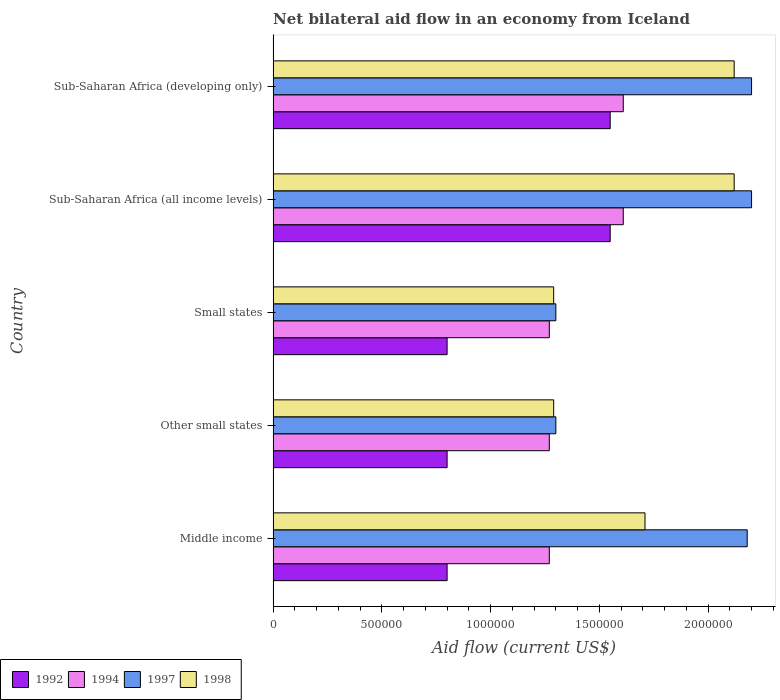Are the number of bars per tick equal to the number of legend labels?
Ensure brevity in your answer.  Yes. What is the label of the 3rd group of bars from the top?
Give a very brief answer. Small states. What is the net bilateral aid flow in 1994 in Small states?
Provide a succinct answer. 1.27e+06. Across all countries, what is the maximum net bilateral aid flow in 1998?
Offer a terse response. 2.12e+06. Across all countries, what is the minimum net bilateral aid flow in 1997?
Offer a terse response. 1.30e+06. In which country was the net bilateral aid flow in 1994 maximum?
Offer a very short reply. Sub-Saharan Africa (all income levels). What is the total net bilateral aid flow in 1992 in the graph?
Offer a terse response. 5.50e+06. What is the difference between the net bilateral aid flow in 1994 in Small states and that in Sub-Saharan Africa (all income levels)?
Your response must be concise. -3.40e+05. What is the difference between the net bilateral aid flow in 1992 in Sub-Saharan Africa (all income levels) and the net bilateral aid flow in 1997 in Sub-Saharan Africa (developing only)?
Keep it short and to the point. -6.50e+05. What is the average net bilateral aid flow in 1994 per country?
Your answer should be compact. 1.41e+06. What is the ratio of the net bilateral aid flow in 1992 in Sub-Saharan Africa (all income levels) to that in Sub-Saharan Africa (developing only)?
Offer a terse response. 1. Is the difference between the net bilateral aid flow in 1998 in Middle income and Sub-Saharan Africa (all income levels) greater than the difference between the net bilateral aid flow in 1994 in Middle income and Sub-Saharan Africa (all income levels)?
Keep it short and to the point. No. What is the difference between the highest and the second highest net bilateral aid flow in 1994?
Provide a short and direct response. 0. What is the difference between the highest and the lowest net bilateral aid flow in 1998?
Ensure brevity in your answer.  8.30e+05. Is it the case that in every country, the sum of the net bilateral aid flow in 1992 and net bilateral aid flow in 1997 is greater than the sum of net bilateral aid flow in 1994 and net bilateral aid flow in 1998?
Your answer should be compact. No. How many bars are there?
Provide a succinct answer. 20. How many countries are there in the graph?
Provide a succinct answer. 5. What is the difference between two consecutive major ticks on the X-axis?
Keep it short and to the point. 5.00e+05. Does the graph contain any zero values?
Ensure brevity in your answer.  No. How are the legend labels stacked?
Give a very brief answer. Horizontal. What is the title of the graph?
Your answer should be very brief. Net bilateral aid flow in an economy from Iceland. Does "2015" appear as one of the legend labels in the graph?
Ensure brevity in your answer.  No. What is the Aid flow (current US$) of 1992 in Middle income?
Offer a terse response. 8.00e+05. What is the Aid flow (current US$) in 1994 in Middle income?
Give a very brief answer. 1.27e+06. What is the Aid flow (current US$) of 1997 in Middle income?
Offer a terse response. 2.18e+06. What is the Aid flow (current US$) in 1998 in Middle income?
Offer a terse response. 1.71e+06. What is the Aid flow (current US$) in 1994 in Other small states?
Ensure brevity in your answer.  1.27e+06. What is the Aid flow (current US$) of 1997 in Other small states?
Give a very brief answer. 1.30e+06. What is the Aid flow (current US$) in 1998 in Other small states?
Your answer should be compact. 1.29e+06. What is the Aid flow (current US$) of 1992 in Small states?
Ensure brevity in your answer.  8.00e+05. What is the Aid flow (current US$) of 1994 in Small states?
Offer a very short reply. 1.27e+06. What is the Aid flow (current US$) in 1997 in Small states?
Ensure brevity in your answer.  1.30e+06. What is the Aid flow (current US$) in 1998 in Small states?
Give a very brief answer. 1.29e+06. What is the Aid flow (current US$) of 1992 in Sub-Saharan Africa (all income levels)?
Ensure brevity in your answer.  1.55e+06. What is the Aid flow (current US$) of 1994 in Sub-Saharan Africa (all income levels)?
Keep it short and to the point. 1.61e+06. What is the Aid flow (current US$) in 1997 in Sub-Saharan Africa (all income levels)?
Give a very brief answer. 2.20e+06. What is the Aid flow (current US$) of 1998 in Sub-Saharan Africa (all income levels)?
Ensure brevity in your answer.  2.12e+06. What is the Aid flow (current US$) in 1992 in Sub-Saharan Africa (developing only)?
Your response must be concise. 1.55e+06. What is the Aid flow (current US$) of 1994 in Sub-Saharan Africa (developing only)?
Ensure brevity in your answer.  1.61e+06. What is the Aid flow (current US$) of 1997 in Sub-Saharan Africa (developing only)?
Your answer should be very brief. 2.20e+06. What is the Aid flow (current US$) in 1998 in Sub-Saharan Africa (developing only)?
Give a very brief answer. 2.12e+06. Across all countries, what is the maximum Aid flow (current US$) in 1992?
Your answer should be compact. 1.55e+06. Across all countries, what is the maximum Aid flow (current US$) of 1994?
Keep it short and to the point. 1.61e+06. Across all countries, what is the maximum Aid flow (current US$) in 1997?
Ensure brevity in your answer.  2.20e+06. Across all countries, what is the maximum Aid flow (current US$) in 1998?
Your response must be concise. 2.12e+06. Across all countries, what is the minimum Aid flow (current US$) of 1992?
Give a very brief answer. 8.00e+05. Across all countries, what is the minimum Aid flow (current US$) of 1994?
Ensure brevity in your answer.  1.27e+06. Across all countries, what is the minimum Aid flow (current US$) in 1997?
Keep it short and to the point. 1.30e+06. Across all countries, what is the minimum Aid flow (current US$) in 1998?
Offer a very short reply. 1.29e+06. What is the total Aid flow (current US$) in 1992 in the graph?
Give a very brief answer. 5.50e+06. What is the total Aid flow (current US$) in 1994 in the graph?
Keep it short and to the point. 7.03e+06. What is the total Aid flow (current US$) of 1997 in the graph?
Your response must be concise. 9.18e+06. What is the total Aid flow (current US$) in 1998 in the graph?
Your answer should be compact. 8.53e+06. What is the difference between the Aid flow (current US$) of 1992 in Middle income and that in Other small states?
Your response must be concise. 0. What is the difference between the Aid flow (current US$) in 1994 in Middle income and that in Other small states?
Keep it short and to the point. 0. What is the difference between the Aid flow (current US$) in 1997 in Middle income and that in Other small states?
Your answer should be very brief. 8.80e+05. What is the difference between the Aid flow (current US$) in 1998 in Middle income and that in Other small states?
Provide a succinct answer. 4.20e+05. What is the difference between the Aid flow (current US$) in 1992 in Middle income and that in Small states?
Provide a succinct answer. 0. What is the difference between the Aid flow (current US$) in 1994 in Middle income and that in Small states?
Make the answer very short. 0. What is the difference between the Aid flow (current US$) in 1997 in Middle income and that in Small states?
Give a very brief answer. 8.80e+05. What is the difference between the Aid flow (current US$) in 1992 in Middle income and that in Sub-Saharan Africa (all income levels)?
Your response must be concise. -7.50e+05. What is the difference between the Aid flow (current US$) of 1998 in Middle income and that in Sub-Saharan Africa (all income levels)?
Ensure brevity in your answer.  -4.10e+05. What is the difference between the Aid flow (current US$) of 1992 in Middle income and that in Sub-Saharan Africa (developing only)?
Offer a terse response. -7.50e+05. What is the difference between the Aid flow (current US$) of 1998 in Middle income and that in Sub-Saharan Africa (developing only)?
Provide a short and direct response. -4.10e+05. What is the difference between the Aid flow (current US$) of 1992 in Other small states and that in Small states?
Provide a succinct answer. 0. What is the difference between the Aid flow (current US$) in 1998 in Other small states and that in Small states?
Make the answer very short. 0. What is the difference between the Aid flow (current US$) in 1992 in Other small states and that in Sub-Saharan Africa (all income levels)?
Your answer should be compact. -7.50e+05. What is the difference between the Aid flow (current US$) in 1997 in Other small states and that in Sub-Saharan Africa (all income levels)?
Your answer should be compact. -9.00e+05. What is the difference between the Aid flow (current US$) of 1998 in Other small states and that in Sub-Saharan Africa (all income levels)?
Keep it short and to the point. -8.30e+05. What is the difference between the Aid flow (current US$) in 1992 in Other small states and that in Sub-Saharan Africa (developing only)?
Provide a succinct answer. -7.50e+05. What is the difference between the Aid flow (current US$) in 1997 in Other small states and that in Sub-Saharan Africa (developing only)?
Your response must be concise. -9.00e+05. What is the difference between the Aid flow (current US$) of 1998 in Other small states and that in Sub-Saharan Africa (developing only)?
Your answer should be compact. -8.30e+05. What is the difference between the Aid flow (current US$) of 1992 in Small states and that in Sub-Saharan Africa (all income levels)?
Provide a short and direct response. -7.50e+05. What is the difference between the Aid flow (current US$) in 1997 in Small states and that in Sub-Saharan Africa (all income levels)?
Your response must be concise. -9.00e+05. What is the difference between the Aid flow (current US$) of 1998 in Small states and that in Sub-Saharan Africa (all income levels)?
Offer a very short reply. -8.30e+05. What is the difference between the Aid flow (current US$) in 1992 in Small states and that in Sub-Saharan Africa (developing only)?
Provide a short and direct response. -7.50e+05. What is the difference between the Aid flow (current US$) of 1997 in Small states and that in Sub-Saharan Africa (developing only)?
Offer a very short reply. -9.00e+05. What is the difference between the Aid flow (current US$) in 1998 in Small states and that in Sub-Saharan Africa (developing only)?
Your answer should be compact. -8.30e+05. What is the difference between the Aid flow (current US$) of 1992 in Sub-Saharan Africa (all income levels) and that in Sub-Saharan Africa (developing only)?
Your response must be concise. 0. What is the difference between the Aid flow (current US$) of 1997 in Sub-Saharan Africa (all income levels) and that in Sub-Saharan Africa (developing only)?
Offer a terse response. 0. What is the difference between the Aid flow (current US$) of 1992 in Middle income and the Aid flow (current US$) of 1994 in Other small states?
Your answer should be compact. -4.70e+05. What is the difference between the Aid flow (current US$) in 1992 in Middle income and the Aid flow (current US$) in 1997 in Other small states?
Your answer should be very brief. -5.00e+05. What is the difference between the Aid flow (current US$) in 1992 in Middle income and the Aid flow (current US$) in 1998 in Other small states?
Offer a very short reply. -4.90e+05. What is the difference between the Aid flow (current US$) in 1994 in Middle income and the Aid flow (current US$) in 1997 in Other small states?
Provide a succinct answer. -3.00e+04. What is the difference between the Aid flow (current US$) of 1997 in Middle income and the Aid flow (current US$) of 1998 in Other small states?
Provide a short and direct response. 8.90e+05. What is the difference between the Aid flow (current US$) of 1992 in Middle income and the Aid flow (current US$) of 1994 in Small states?
Give a very brief answer. -4.70e+05. What is the difference between the Aid flow (current US$) in 1992 in Middle income and the Aid flow (current US$) in 1997 in Small states?
Provide a short and direct response. -5.00e+05. What is the difference between the Aid flow (current US$) of 1992 in Middle income and the Aid flow (current US$) of 1998 in Small states?
Offer a very short reply. -4.90e+05. What is the difference between the Aid flow (current US$) of 1994 in Middle income and the Aid flow (current US$) of 1997 in Small states?
Make the answer very short. -3.00e+04. What is the difference between the Aid flow (current US$) of 1994 in Middle income and the Aid flow (current US$) of 1998 in Small states?
Your answer should be very brief. -2.00e+04. What is the difference between the Aid flow (current US$) in 1997 in Middle income and the Aid flow (current US$) in 1998 in Small states?
Provide a short and direct response. 8.90e+05. What is the difference between the Aid flow (current US$) in 1992 in Middle income and the Aid flow (current US$) in 1994 in Sub-Saharan Africa (all income levels)?
Give a very brief answer. -8.10e+05. What is the difference between the Aid flow (current US$) in 1992 in Middle income and the Aid flow (current US$) in 1997 in Sub-Saharan Africa (all income levels)?
Your answer should be compact. -1.40e+06. What is the difference between the Aid flow (current US$) of 1992 in Middle income and the Aid flow (current US$) of 1998 in Sub-Saharan Africa (all income levels)?
Give a very brief answer. -1.32e+06. What is the difference between the Aid flow (current US$) in 1994 in Middle income and the Aid flow (current US$) in 1997 in Sub-Saharan Africa (all income levels)?
Provide a short and direct response. -9.30e+05. What is the difference between the Aid flow (current US$) in 1994 in Middle income and the Aid flow (current US$) in 1998 in Sub-Saharan Africa (all income levels)?
Provide a succinct answer. -8.50e+05. What is the difference between the Aid flow (current US$) of 1992 in Middle income and the Aid flow (current US$) of 1994 in Sub-Saharan Africa (developing only)?
Your answer should be compact. -8.10e+05. What is the difference between the Aid flow (current US$) in 1992 in Middle income and the Aid flow (current US$) in 1997 in Sub-Saharan Africa (developing only)?
Make the answer very short. -1.40e+06. What is the difference between the Aid flow (current US$) in 1992 in Middle income and the Aid flow (current US$) in 1998 in Sub-Saharan Africa (developing only)?
Give a very brief answer. -1.32e+06. What is the difference between the Aid flow (current US$) of 1994 in Middle income and the Aid flow (current US$) of 1997 in Sub-Saharan Africa (developing only)?
Provide a short and direct response. -9.30e+05. What is the difference between the Aid flow (current US$) in 1994 in Middle income and the Aid flow (current US$) in 1998 in Sub-Saharan Africa (developing only)?
Ensure brevity in your answer.  -8.50e+05. What is the difference between the Aid flow (current US$) in 1992 in Other small states and the Aid flow (current US$) in 1994 in Small states?
Give a very brief answer. -4.70e+05. What is the difference between the Aid flow (current US$) of 1992 in Other small states and the Aid flow (current US$) of 1997 in Small states?
Provide a succinct answer. -5.00e+05. What is the difference between the Aid flow (current US$) in 1992 in Other small states and the Aid flow (current US$) in 1998 in Small states?
Provide a short and direct response. -4.90e+05. What is the difference between the Aid flow (current US$) of 1994 in Other small states and the Aid flow (current US$) of 1997 in Small states?
Provide a succinct answer. -3.00e+04. What is the difference between the Aid flow (current US$) in 1992 in Other small states and the Aid flow (current US$) in 1994 in Sub-Saharan Africa (all income levels)?
Provide a short and direct response. -8.10e+05. What is the difference between the Aid flow (current US$) of 1992 in Other small states and the Aid flow (current US$) of 1997 in Sub-Saharan Africa (all income levels)?
Provide a short and direct response. -1.40e+06. What is the difference between the Aid flow (current US$) of 1992 in Other small states and the Aid flow (current US$) of 1998 in Sub-Saharan Africa (all income levels)?
Provide a short and direct response. -1.32e+06. What is the difference between the Aid flow (current US$) of 1994 in Other small states and the Aid flow (current US$) of 1997 in Sub-Saharan Africa (all income levels)?
Offer a terse response. -9.30e+05. What is the difference between the Aid flow (current US$) in 1994 in Other small states and the Aid flow (current US$) in 1998 in Sub-Saharan Africa (all income levels)?
Ensure brevity in your answer.  -8.50e+05. What is the difference between the Aid flow (current US$) in 1997 in Other small states and the Aid flow (current US$) in 1998 in Sub-Saharan Africa (all income levels)?
Offer a terse response. -8.20e+05. What is the difference between the Aid flow (current US$) of 1992 in Other small states and the Aid flow (current US$) of 1994 in Sub-Saharan Africa (developing only)?
Offer a very short reply. -8.10e+05. What is the difference between the Aid flow (current US$) of 1992 in Other small states and the Aid flow (current US$) of 1997 in Sub-Saharan Africa (developing only)?
Make the answer very short. -1.40e+06. What is the difference between the Aid flow (current US$) in 1992 in Other small states and the Aid flow (current US$) in 1998 in Sub-Saharan Africa (developing only)?
Your response must be concise. -1.32e+06. What is the difference between the Aid flow (current US$) in 1994 in Other small states and the Aid flow (current US$) in 1997 in Sub-Saharan Africa (developing only)?
Provide a succinct answer. -9.30e+05. What is the difference between the Aid flow (current US$) in 1994 in Other small states and the Aid flow (current US$) in 1998 in Sub-Saharan Africa (developing only)?
Give a very brief answer. -8.50e+05. What is the difference between the Aid flow (current US$) in 1997 in Other small states and the Aid flow (current US$) in 1998 in Sub-Saharan Africa (developing only)?
Make the answer very short. -8.20e+05. What is the difference between the Aid flow (current US$) in 1992 in Small states and the Aid flow (current US$) in 1994 in Sub-Saharan Africa (all income levels)?
Ensure brevity in your answer.  -8.10e+05. What is the difference between the Aid flow (current US$) of 1992 in Small states and the Aid flow (current US$) of 1997 in Sub-Saharan Africa (all income levels)?
Your answer should be very brief. -1.40e+06. What is the difference between the Aid flow (current US$) of 1992 in Small states and the Aid flow (current US$) of 1998 in Sub-Saharan Africa (all income levels)?
Your response must be concise. -1.32e+06. What is the difference between the Aid flow (current US$) of 1994 in Small states and the Aid flow (current US$) of 1997 in Sub-Saharan Africa (all income levels)?
Offer a very short reply. -9.30e+05. What is the difference between the Aid flow (current US$) of 1994 in Small states and the Aid flow (current US$) of 1998 in Sub-Saharan Africa (all income levels)?
Keep it short and to the point. -8.50e+05. What is the difference between the Aid flow (current US$) of 1997 in Small states and the Aid flow (current US$) of 1998 in Sub-Saharan Africa (all income levels)?
Ensure brevity in your answer.  -8.20e+05. What is the difference between the Aid flow (current US$) of 1992 in Small states and the Aid flow (current US$) of 1994 in Sub-Saharan Africa (developing only)?
Your response must be concise. -8.10e+05. What is the difference between the Aid flow (current US$) of 1992 in Small states and the Aid flow (current US$) of 1997 in Sub-Saharan Africa (developing only)?
Provide a short and direct response. -1.40e+06. What is the difference between the Aid flow (current US$) of 1992 in Small states and the Aid flow (current US$) of 1998 in Sub-Saharan Africa (developing only)?
Your response must be concise. -1.32e+06. What is the difference between the Aid flow (current US$) in 1994 in Small states and the Aid flow (current US$) in 1997 in Sub-Saharan Africa (developing only)?
Provide a short and direct response. -9.30e+05. What is the difference between the Aid flow (current US$) in 1994 in Small states and the Aid flow (current US$) in 1998 in Sub-Saharan Africa (developing only)?
Keep it short and to the point. -8.50e+05. What is the difference between the Aid flow (current US$) of 1997 in Small states and the Aid flow (current US$) of 1998 in Sub-Saharan Africa (developing only)?
Make the answer very short. -8.20e+05. What is the difference between the Aid flow (current US$) in 1992 in Sub-Saharan Africa (all income levels) and the Aid flow (current US$) in 1994 in Sub-Saharan Africa (developing only)?
Provide a succinct answer. -6.00e+04. What is the difference between the Aid flow (current US$) in 1992 in Sub-Saharan Africa (all income levels) and the Aid flow (current US$) in 1997 in Sub-Saharan Africa (developing only)?
Your response must be concise. -6.50e+05. What is the difference between the Aid flow (current US$) in 1992 in Sub-Saharan Africa (all income levels) and the Aid flow (current US$) in 1998 in Sub-Saharan Africa (developing only)?
Keep it short and to the point. -5.70e+05. What is the difference between the Aid flow (current US$) of 1994 in Sub-Saharan Africa (all income levels) and the Aid flow (current US$) of 1997 in Sub-Saharan Africa (developing only)?
Give a very brief answer. -5.90e+05. What is the difference between the Aid flow (current US$) in 1994 in Sub-Saharan Africa (all income levels) and the Aid flow (current US$) in 1998 in Sub-Saharan Africa (developing only)?
Offer a very short reply. -5.10e+05. What is the difference between the Aid flow (current US$) of 1997 in Sub-Saharan Africa (all income levels) and the Aid flow (current US$) of 1998 in Sub-Saharan Africa (developing only)?
Make the answer very short. 8.00e+04. What is the average Aid flow (current US$) in 1992 per country?
Provide a short and direct response. 1.10e+06. What is the average Aid flow (current US$) of 1994 per country?
Give a very brief answer. 1.41e+06. What is the average Aid flow (current US$) of 1997 per country?
Offer a terse response. 1.84e+06. What is the average Aid flow (current US$) of 1998 per country?
Provide a short and direct response. 1.71e+06. What is the difference between the Aid flow (current US$) of 1992 and Aid flow (current US$) of 1994 in Middle income?
Make the answer very short. -4.70e+05. What is the difference between the Aid flow (current US$) in 1992 and Aid flow (current US$) in 1997 in Middle income?
Your response must be concise. -1.38e+06. What is the difference between the Aid flow (current US$) in 1992 and Aid flow (current US$) in 1998 in Middle income?
Make the answer very short. -9.10e+05. What is the difference between the Aid flow (current US$) of 1994 and Aid flow (current US$) of 1997 in Middle income?
Your response must be concise. -9.10e+05. What is the difference between the Aid flow (current US$) of 1994 and Aid flow (current US$) of 1998 in Middle income?
Make the answer very short. -4.40e+05. What is the difference between the Aid flow (current US$) in 1992 and Aid flow (current US$) in 1994 in Other small states?
Ensure brevity in your answer.  -4.70e+05. What is the difference between the Aid flow (current US$) in 1992 and Aid flow (current US$) in 1997 in Other small states?
Your answer should be compact. -5.00e+05. What is the difference between the Aid flow (current US$) in 1992 and Aid flow (current US$) in 1998 in Other small states?
Offer a very short reply. -4.90e+05. What is the difference between the Aid flow (current US$) in 1994 and Aid flow (current US$) in 1997 in Other small states?
Ensure brevity in your answer.  -3.00e+04. What is the difference between the Aid flow (current US$) in 1992 and Aid flow (current US$) in 1994 in Small states?
Offer a terse response. -4.70e+05. What is the difference between the Aid flow (current US$) in 1992 and Aid flow (current US$) in 1997 in Small states?
Offer a very short reply. -5.00e+05. What is the difference between the Aid flow (current US$) of 1992 and Aid flow (current US$) of 1998 in Small states?
Your answer should be very brief. -4.90e+05. What is the difference between the Aid flow (current US$) of 1994 and Aid flow (current US$) of 1998 in Small states?
Offer a terse response. -2.00e+04. What is the difference between the Aid flow (current US$) in 1992 and Aid flow (current US$) in 1994 in Sub-Saharan Africa (all income levels)?
Your answer should be compact. -6.00e+04. What is the difference between the Aid flow (current US$) of 1992 and Aid flow (current US$) of 1997 in Sub-Saharan Africa (all income levels)?
Provide a succinct answer. -6.50e+05. What is the difference between the Aid flow (current US$) of 1992 and Aid flow (current US$) of 1998 in Sub-Saharan Africa (all income levels)?
Offer a very short reply. -5.70e+05. What is the difference between the Aid flow (current US$) in 1994 and Aid flow (current US$) in 1997 in Sub-Saharan Africa (all income levels)?
Provide a short and direct response. -5.90e+05. What is the difference between the Aid flow (current US$) of 1994 and Aid flow (current US$) of 1998 in Sub-Saharan Africa (all income levels)?
Your answer should be compact. -5.10e+05. What is the difference between the Aid flow (current US$) of 1992 and Aid flow (current US$) of 1994 in Sub-Saharan Africa (developing only)?
Your answer should be compact. -6.00e+04. What is the difference between the Aid flow (current US$) of 1992 and Aid flow (current US$) of 1997 in Sub-Saharan Africa (developing only)?
Ensure brevity in your answer.  -6.50e+05. What is the difference between the Aid flow (current US$) in 1992 and Aid flow (current US$) in 1998 in Sub-Saharan Africa (developing only)?
Make the answer very short. -5.70e+05. What is the difference between the Aid flow (current US$) in 1994 and Aid flow (current US$) in 1997 in Sub-Saharan Africa (developing only)?
Make the answer very short. -5.90e+05. What is the difference between the Aid flow (current US$) of 1994 and Aid flow (current US$) of 1998 in Sub-Saharan Africa (developing only)?
Provide a short and direct response. -5.10e+05. What is the ratio of the Aid flow (current US$) of 1992 in Middle income to that in Other small states?
Offer a terse response. 1. What is the ratio of the Aid flow (current US$) in 1997 in Middle income to that in Other small states?
Provide a succinct answer. 1.68. What is the ratio of the Aid flow (current US$) in 1998 in Middle income to that in Other small states?
Your answer should be very brief. 1.33. What is the ratio of the Aid flow (current US$) of 1994 in Middle income to that in Small states?
Offer a terse response. 1. What is the ratio of the Aid flow (current US$) of 1997 in Middle income to that in Small states?
Offer a very short reply. 1.68. What is the ratio of the Aid flow (current US$) in 1998 in Middle income to that in Small states?
Offer a terse response. 1.33. What is the ratio of the Aid flow (current US$) of 1992 in Middle income to that in Sub-Saharan Africa (all income levels)?
Offer a very short reply. 0.52. What is the ratio of the Aid flow (current US$) in 1994 in Middle income to that in Sub-Saharan Africa (all income levels)?
Your answer should be compact. 0.79. What is the ratio of the Aid flow (current US$) in 1997 in Middle income to that in Sub-Saharan Africa (all income levels)?
Your response must be concise. 0.99. What is the ratio of the Aid flow (current US$) of 1998 in Middle income to that in Sub-Saharan Africa (all income levels)?
Make the answer very short. 0.81. What is the ratio of the Aid flow (current US$) in 1992 in Middle income to that in Sub-Saharan Africa (developing only)?
Ensure brevity in your answer.  0.52. What is the ratio of the Aid flow (current US$) of 1994 in Middle income to that in Sub-Saharan Africa (developing only)?
Your answer should be very brief. 0.79. What is the ratio of the Aid flow (current US$) of 1997 in Middle income to that in Sub-Saharan Africa (developing only)?
Your answer should be compact. 0.99. What is the ratio of the Aid flow (current US$) of 1998 in Middle income to that in Sub-Saharan Africa (developing only)?
Keep it short and to the point. 0.81. What is the ratio of the Aid flow (current US$) in 1992 in Other small states to that in Small states?
Ensure brevity in your answer.  1. What is the ratio of the Aid flow (current US$) of 1997 in Other small states to that in Small states?
Your answer should be compact. 1. What is the ratio of the Aid flow (current US$) in 1992 in Other small states to that in Sub-Saharan Africa (all income levels)?
Ensure brevity in your answer.  0.52. What is the ratio of the Aid flow (current US$) in 1994 in Other small states to that in Sub-Saharan Africa (all income levels)?
Your answer should be very brief. 0.79. What is the ratio of the Aid flow (current US$) of 1997 in Other small states to that in Sub-Saharan Africa (all income levels)?
Offer a very short reply. 0.59. What is the ratio of the Aid flow (current US$) in 1998 in Other small states to that in Sub-Saharan Africa (all income levels)?
Keep it short and to the point. 0.61. What is the ratio of the Aid flow (current US$) of 1992 in Other small states to that in Sub-Saharan Africa (developing only)?
Your answer should be compact. 0.52. What is the ratio of the Aid flow (current US$) of 1994 in Other small states to that in Sub-Saharan Africa (developing only)?
Your response must be concise. 0.79. What is the ratio of the Aid flow (current US$) of 1997 in Other small states to that in Sub-Saharan Africa (developing only)?
Your answer should be very brief. 0.59. What is the ratio of the Aid flow (current US$) in 1998 in Other small states to that in Sub-Saharan Africa (developing only)?
Ensure brevity in your answer.  0.61. What is the ratio of the Aid flow (current US$) of 1992 in Small states to that in Sub-Saharan Africa (all income levels)?
Offer a terse response. 0.52. What is the ratio of the Aid flow (current US$) in 1994 in Small states to that in Sub-Saharan Africa (all income levels)?
Make the answer very short. 0.79. What is the ratio of the Aid flow (current US$) in 1997 in Small states to that in Sub-Saharan Africa (all income levels)?
Your response must be concise. 0.59. What is the ratio of the Aid flow (current US$) of 1998 in Small states to that in Sub-Saharan Africa (all income levels)?
Offer a very short reply. 0.61. What is the ratio of the Aid flow (current US$) in 1992 in Small states to that in Sub-Saharan Africa (developing only)?
Offer a very short reply. 0.52. What is the ratio of the Aid flow (current US$) of 1994 in Small states to that in Sub-Saharan Africa (developing only)?
Your answer should be compact. 0.79. What is the ratio of the Aid flow (current US$) of 1997 in Small states to that in Sub-Saharan Africa (developing only)?
Make the answer very short. 0.59. What is the ratio of the Aid flow (current US$) of 1998 in Small states to that in Sub-Saharan Africa (developing only)?
Offer a terse response. 0.61. What is the ratio of the Aid flow (current US$) in 1992 in Sub-Saharan Africa (all income levels) to that in Sub-Saharan Africa (developing only)?
Ensure brevity in your answer.  1. What is the ratio of the Aid flow (current US$) in 1994 in Sub-Saharan Africa (all income levels) to that in Sub-Saharan Africa (developing only)?
Your answer should be compact. 1. What is the ratio of the Aid flow (current US$) of 1997 in Sub-Saharan Africa (all income levels) to that in Sub-Saharan Africa (developing only)?
Your response must be concise. 1. What is the ratio of the Aid flow (current US$) of 1998 in Sub-Saharan Africa (all income levels) to that in Sub-Saharan Africa (developing only)?
Make the answer very short. 1. What is the difference between the highest and the second highest Aid flow (current US$) of 1992?
Keep it short and to the point. 0. What is the difference between the highest and the second highest Aid flow (current US$) of 1994?
Your answer should be compact. 0. What is the difference between the highest and the second highest Aid flow (current US$) of 1997?
Give a very brief answer. 0. What is the difference between the highest and the second highest Aid flow (current US$) of 1998?
Provide a succinct answer. 0. What is the difference between the highest and the lowest Aid flow (current US$) of 1992?
Your response must be concise. 7.50e+05. What is the difference between the highest and the lowest Aid flow (current US$) of 1998?
Offer a very short reply. 8.30e+05. 